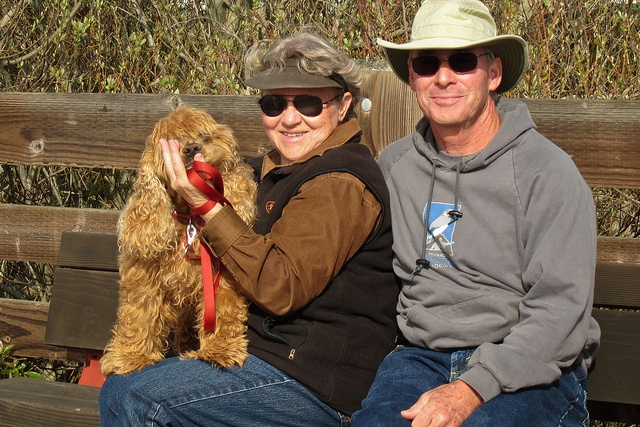Describe the objects in this image and their specific colors. I can see people in olive, gray, and black tones, people in olive, black, brown, gray, and maroon tones, bench in olive, maroon, gray, and black tones, dog in olive, brown, tan, and maroon tones, and bench in olive, gray, and black tones in this image. 